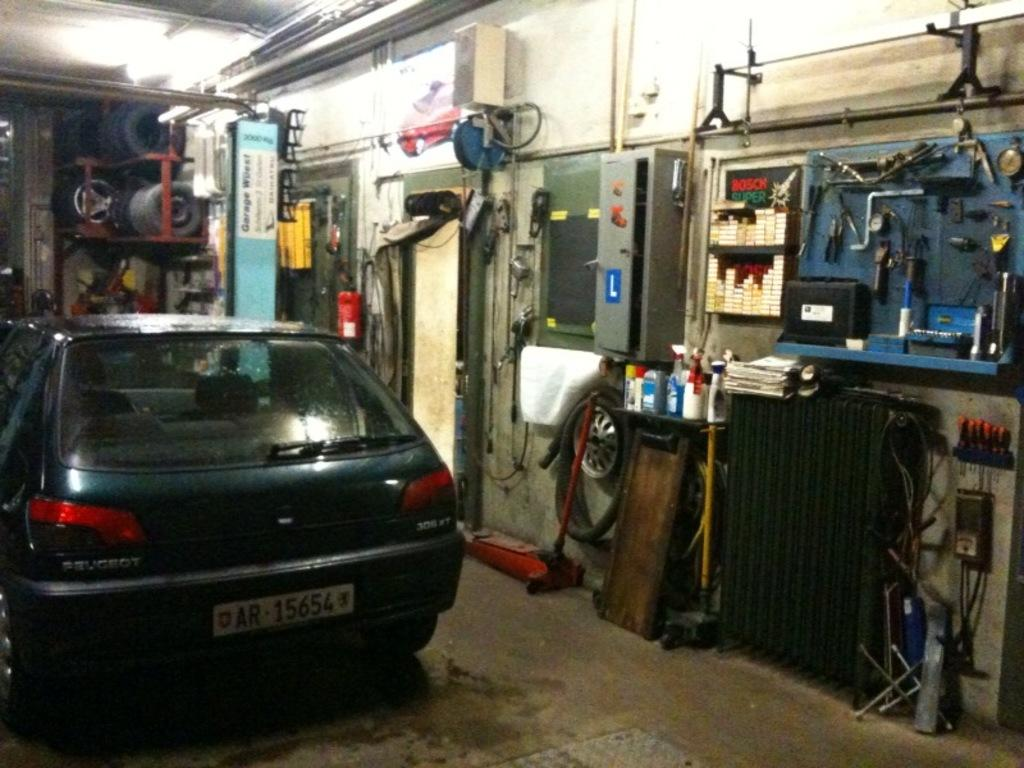What is the main subject in the center of the image? There is a car in the center of the image. Where is the image taken? The image is taken in a mechanic shed. What can be seen in the image that might be used for repairing the car? There are tools visible in the image. What part of the car is present in the image? A rim is present in the image. What other object can be seen in the image? A tube is visible in the image. What else is present in the image besides the car and tools? There are other objects in the image. What can be seen at the top of the image? There are iron poles at the top of the image. What letter is written on the car in the image? There is no letter written on the car in the image. What type of downtown scene can be seen in the image? The image is taken in a mechanic shed, not a downtown scene. 